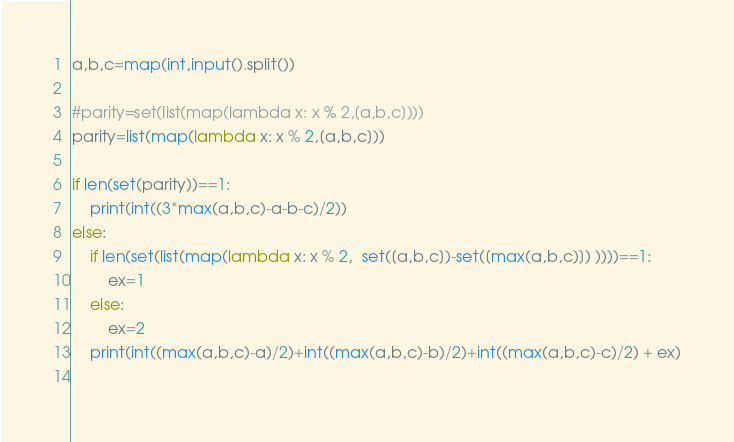<code> <loc_0><loc_0><loc_500><loc_500><_Python_>a,b,c=map(int,input().split())

#parity=set(list(map(lambda x: x % 2,[a,b,c])))
parity=list(map(lambda x: x % 2,[a,b,c]))

if len(set(parity))==1:
    print(int((3*max(a,b,c)-a-b-c)/2))
else:
    if len(set(list(map(lambda x: x % 2,  set([a,b,c])-set([max(a,b,c)]) ))))==1:
        ex=1
    else:
        ex=2
    print(int((max(a,b,c)-a)/2)+int((max(a,b,c)-b)/2)+int((max(a,b,c)-c)/2) + ex)
    </code> 